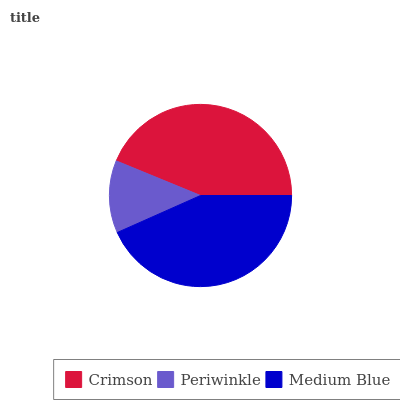Is Periwinkle the minimum?
Answer yes or no. Yes. Is Crimson the maximum?
Answer yes or no. Yes. Is Medium Blue the minimum?
Answer yes or no. No. Is Medium Blue the maximum?
Answer yes or no. No. Is Medium Blue greater than Periwinkle?
Answer yes or no. Yes. Is Periwinkle less than Medium Blue?
Answer yes or no. Yes. Is Periwinkle greater than Medium Blue?
Answer yes or no. No. Is Medium Blue less than Periwinkle?
Answer yes or no. No. Is Medium Blue the high median?
Answer yes or no. Yes. Is Medium Blue the low median?
Answer yes or no. Yes. Is Periwinkle the high median?
Answer yes or no. No. Is Periwinkle the low median?
Answer yes or no. No. 